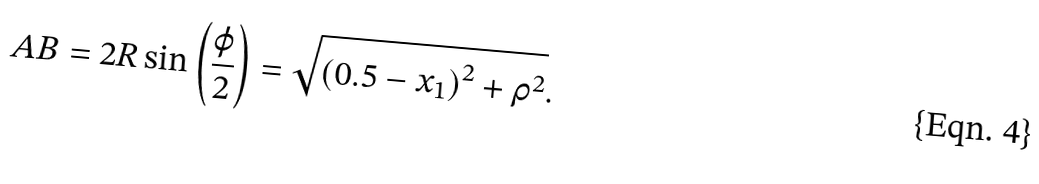<formula> <loc_0><loc_0><loc_500><loc_500>A B = 2 R \sin \left ( \frac { \varphi } { 2 } \right ) = \sqrt { \left ( 0 . 5 - x _ { 1 } \right ) ^ { 2 } + \rho ^ { 2 } } .</formula> 